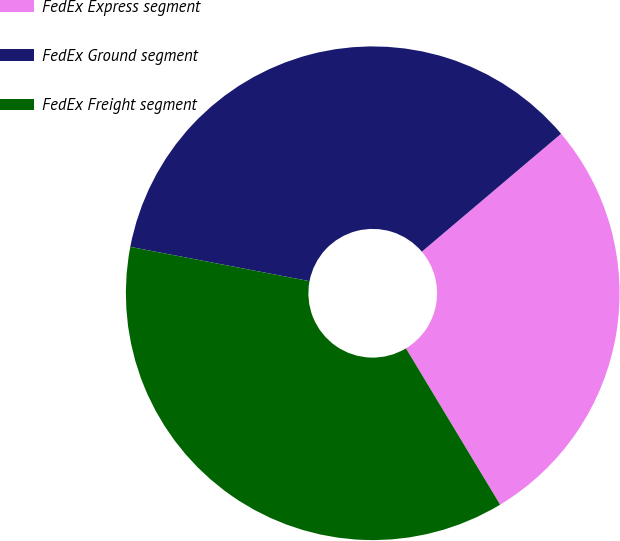Convert chart to OTSL. <chart><loc_0><loc_0><loc_500><loc_500><pie_chart><fcel>FedEx Express segment<fcel>FedEx Ground segment<fcel>FedEx Freight segment<nl><fcel>27.55%<fcel>35.81%<fcel>36.64%<nl></chart> 